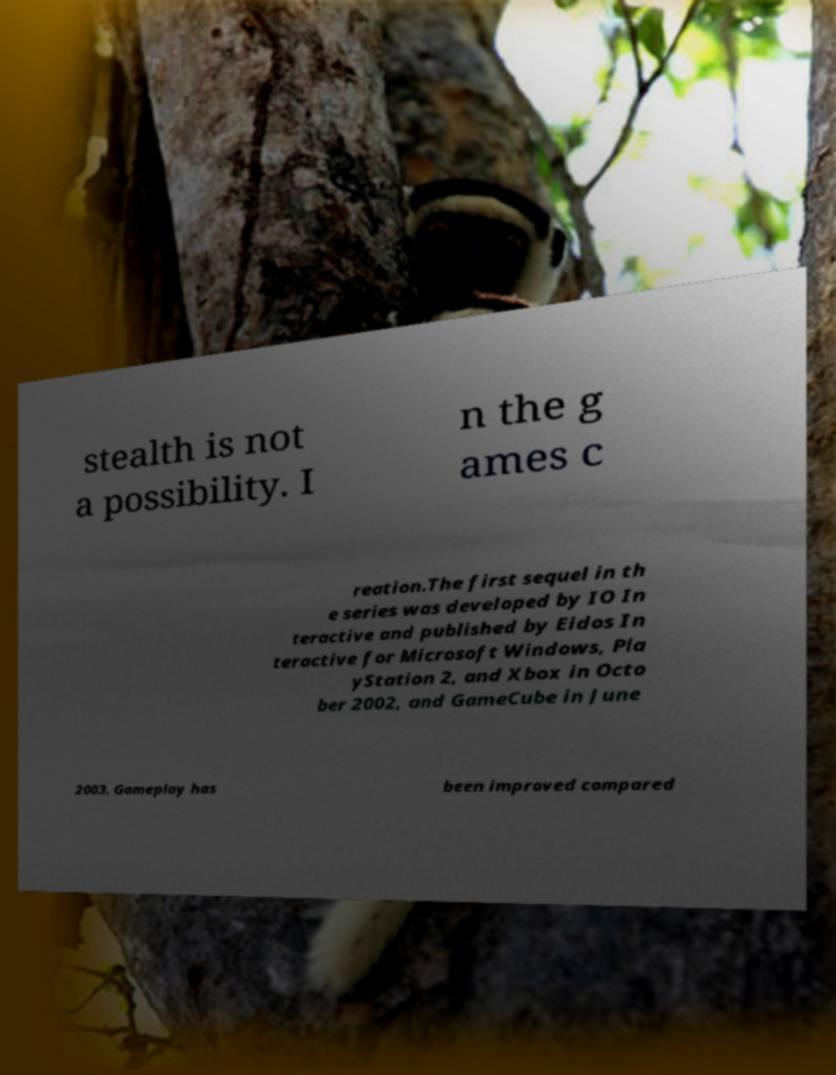Please read and relay the text visible in this image. What does it say? stealth is not a possibility. I n the g ames c reation.The first sequel in th e series was developed by IO In teractive and published by Eidos In teractive for Microsoft Windows, Pla yStation 2, and Xbox in Octo ber 2002, and GameCube in June 2003. Gameplay has been improved compared 